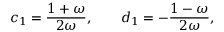<formula> <loc_0><loc_0><loc_500><loc_500>c _ { 1 } = { \frac { 1 + \omega } { 2 \omega } } , \quad d _ { 1 } = - { \frac { 1 - \omega } { 2 \omega } } ,</formula> 